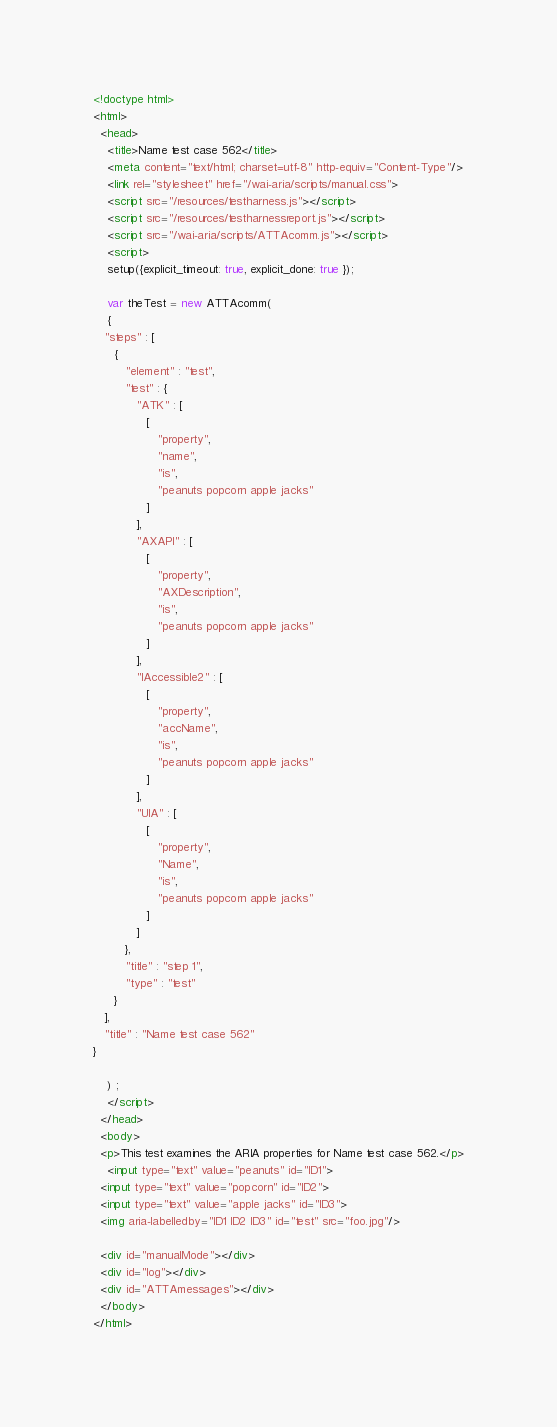<code> <loc_0><loc_0><loc_500><loc_500><_HTML_><!doctype html>
<html>
  <head>
    <title>Name test case 562</title>
    <meta content="text/html; charset=utf-8" http-equiv="Content-Type"/>
    <link rel="stylesheet" href="/wai-aria/scripts/manual.css">
    <script src="/resources/testharness.js"></script>
    <script src="/resources/testharnessreport.js"></script>
    <script src="/wai-aria/scripts/ATTAcomm.js"></script>
    <script>
    setup({explicit_timeout: true, explicit_done: true });

    var theTest = new ATTAcomm(
    {
   "steps" : [
      {
         "element" : "test",
         "test" : {
            "ATK" : [
               [
                  "property",
                  "name",
                  "is",
                  "peanuts popcorn apple jacks"
               ]
            ],
            "AXAPI" : [
               [
                  "property",
                  "AXDescription",
                  "is",
                  "peanuts popcorn apple jacks"
               ]
            ],
            "IAccessible2" : [
               [
                  "property",
                  "accName",
                  "is",
                  "peanuts popcorn apple jacks"
               ]
            ],
            "UIA" : [
               [
                  "property",
                  "Name",
                  "is",
                  "peanuts popcorn apple jacks"
               ]
            ]
         },
         "title" : "step 1",
         "type" : "test"
      }
   ],
   "title" : "Name test case 562"
}

    ) ;
    </script>
  </head>
  <body>
  <p>This test examines the ARIA properties for Name test case 562.</p>
    <input type="text" value="peanuts" id="ID1">
  <input type="text" value="popcorn" id="ID2">
  <input type="text" value="apple jacks" id="ID3">
  <img aria-labelledby="ID1 ID2 ID3" id="test" src="foo.jpg"/>

  <div id="manualMode"></div>
  <div id="log"></div>
  <div id="ATTAmessages"></div>
  </body>
</html>
</code> 